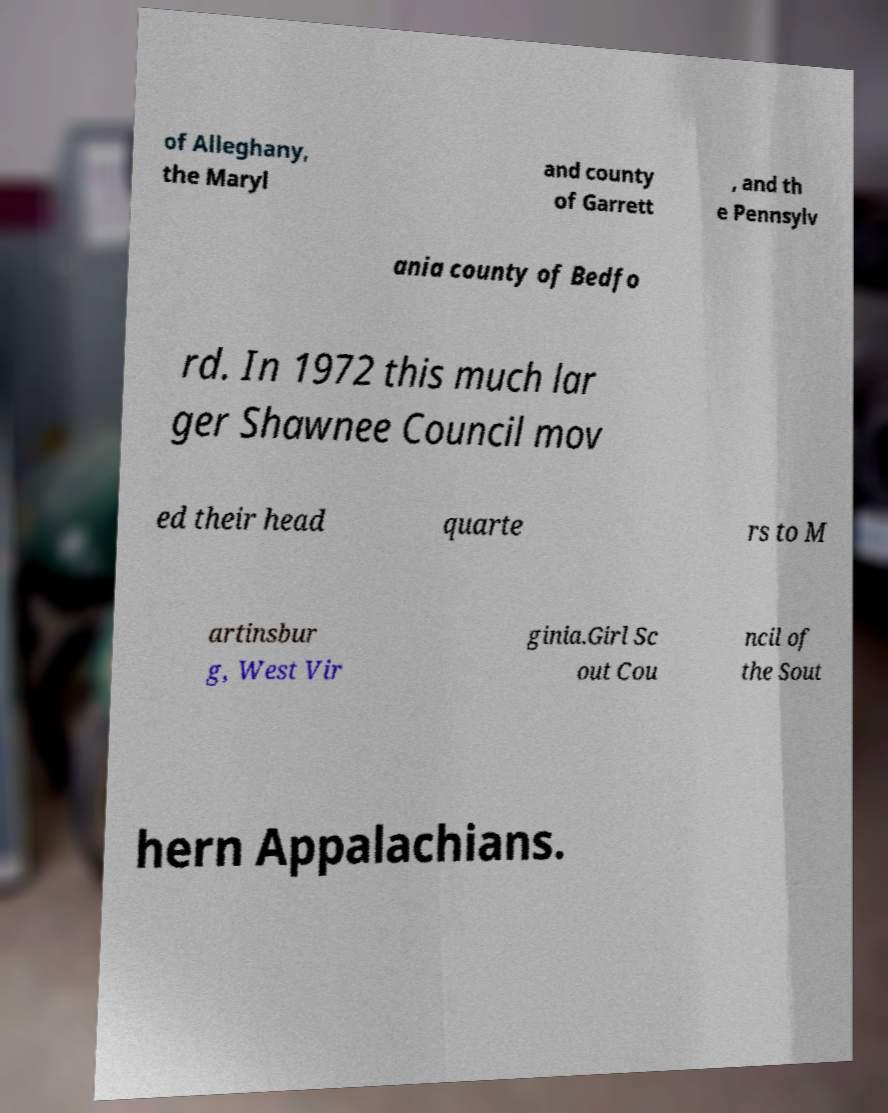For documentation purposes, I need the text within this image transcribed. Could you provide that? of Alleghany, the Maryl and county of Garrett , and th e Pennsylv ania county of Bedfo rd. In 1972 this much lar ger Shawnee Council mov ed their head quarte rs to M artinsbur g, West Vir ginia.Girl Sc out Cou ncil of the Sout hern Appalachians. 